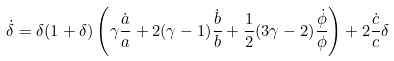<formula> <loc_0><loc_0><loc_500><loc_500>\dot { \delta } = \delta ( 1 + \delta ) \left ( \gamma \frac { \dot { a } } { a } + 2 ( \gamma - 1 ) \frac { \dot { b } } { b } + \frac { 1 } { 2 } ( 3 \gamma - 2 ) \frac { \dot { \phi } } { \phi } \right ) + 2 \frac { \dot { c } } { c } \delta</formula> 